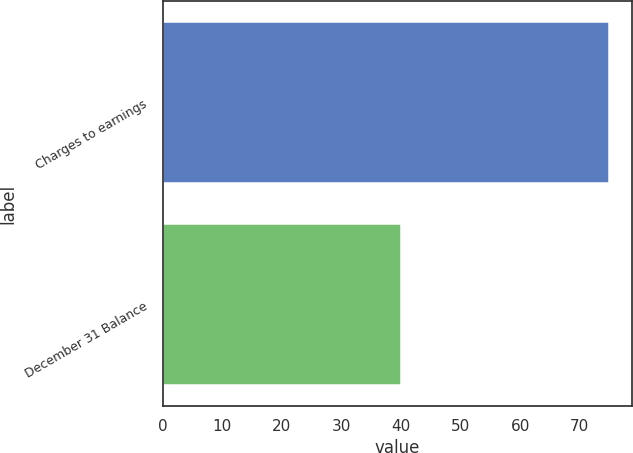Convert chart to OTSL. <chart><loc_0><loc_0><loc_500><loc_500><bar_chart><fcel>Charges to earnings<fcel>December 31 Balance<nl><fcel>75<fcel>40<nl></chart> 